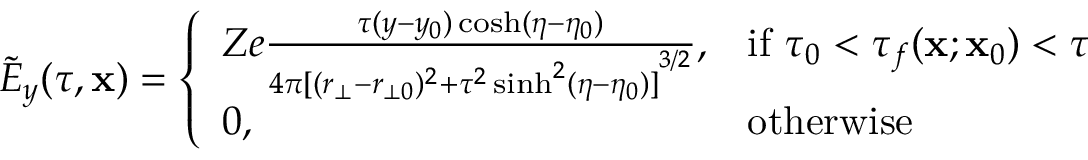<formula> <loc_0><loc_0><loc_500><loc_500>\tilde { E } _ { y } ( \tau , x ) = \left \{ \begin{array} { l l } { Z e \frac { \tau ( y - y _ { 0 } ) \cosh ( \eta - \eta _ { 0 } ) } { 4 \pi { [ ( r _ { \bot } - r _ { \bot 0 } ) ^ { 2 } + \tau ^ { 2 } \sinh ^ { 2 } ( \eta - \eta _ { 0 } ) ] } ^ { 3 / 2 } } , } & { i f \tau _ { 0 } < \tau _ { f } ( x ; x _ { 0 } ) < \tau } \\ { 0 , } & { o t h e r w i s e } \end{array}</formula> 